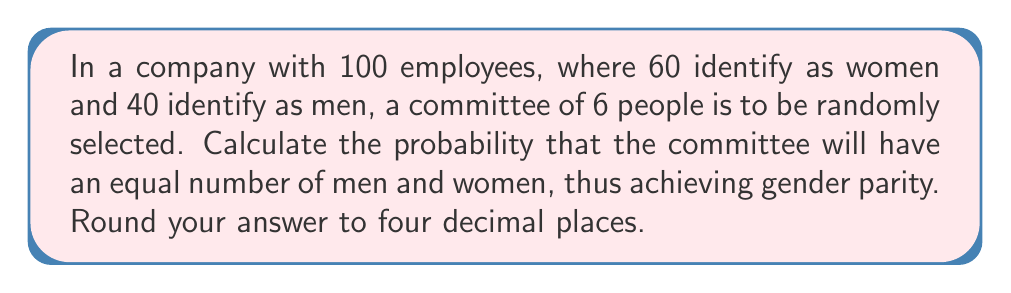Show me your answer to this math problem. Let's approach this step-by-step:

1) For gender parity in a committee of 6, we need 3 women and 3 men.

2) We can calculate this using the hypergeometric distribution:

   $$P(\text{3 women and 3 men}) = \frac{\binom{60}{3} \cdot \binom{40}{3}}{\binom{100}{6}}$$

3) Let's calculate each part:

   a) $\binom{60}{3}$ (ways to choose 3 women from 60):
      $$\binom{60}{3} = \frac{60!}{3!(60-3)!} = \frac{60 \cdot 59 \cdot 58}{3 \cdot 2 \cdot 1} = 34220$$

   b) $\binom{40}{3}$ (ways to choose 3 men from 40):
      $$\binom{40}{3} = \frac{40!}{3!(40-3)!} = \frac{40 \cdot 39 \cdot 38}{3 \cdot 2 \cdot 1} = 9880$$

   c) $\binom{100}{6}$ (total ways to choose 6 people from 100):
      $$\binom{100}{6} = \frac{100!}{6!(100-6)!} = 1192052400$$

4) Now, let's put it all together:

   $$P(\text{3 women and 3 men}) = \frac{34220 \cdot 9880}{1192052400} = \frac{338093600}{1192052400} \approx 0.2835$$

5) Rounding to four decimal places: 0.2835
Answer: 0.2835 